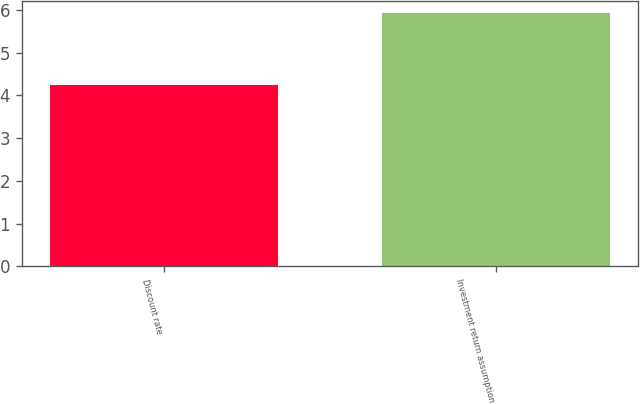<chart> <loc_0><loc_0><loc_500><loc_500><bar_chart><fcel>Discount rate<fcel>Investment return assumption<nl><fcel>4.24<fcel>5.92<nl></chart> 